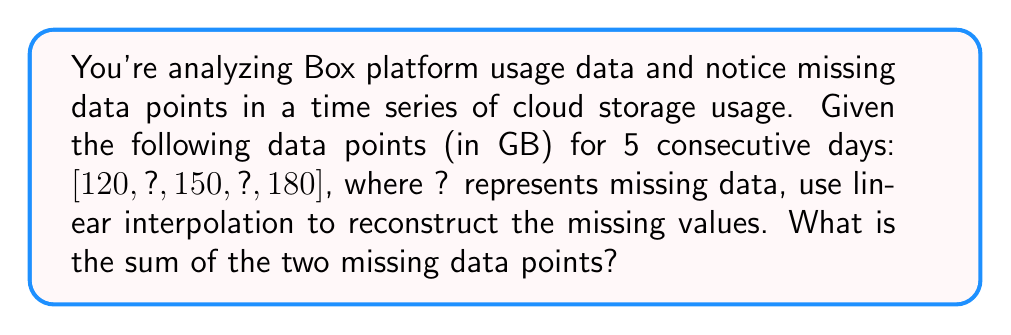What is the answer to this math problem? To solve this problem, we'll use linear interpolation to estimate the missing data points. Let's approach this step-by-step:

1) We have data for days 1, 3, and 5: [120, 150, 180]

2) Let's interpolate for day 2:
   $$y_2 = y_1 + \frac{y_3 - y_1}{x_3 - x_1}(x_2 - x_1)$$
   where $x$ represents the day and $y$ represents the storage usage.

   $$y_2 = 120 + \frac{150 - 120}{3 - 1}(2 - 1) = 120 + 15 = 135$$

3) Now, let's interpolate for day 4:
   $$y_4 = y_3 + \frac{y_5 - y_3}{x_5 - x_3}(x_4 - x_3)$$

   $$y_4 = 150 + \frac{180 - 150}{5 - 3}(4 - 3) = 150 + 15 = 165$$

4) The two missing data points are 135 GB and 165 GB.

5) The sum of these missing data points is:
   $$135 + 165 = 300$$

Therefore, the sum of the two missing data points is 300 GB.
Answer: 300 GB 